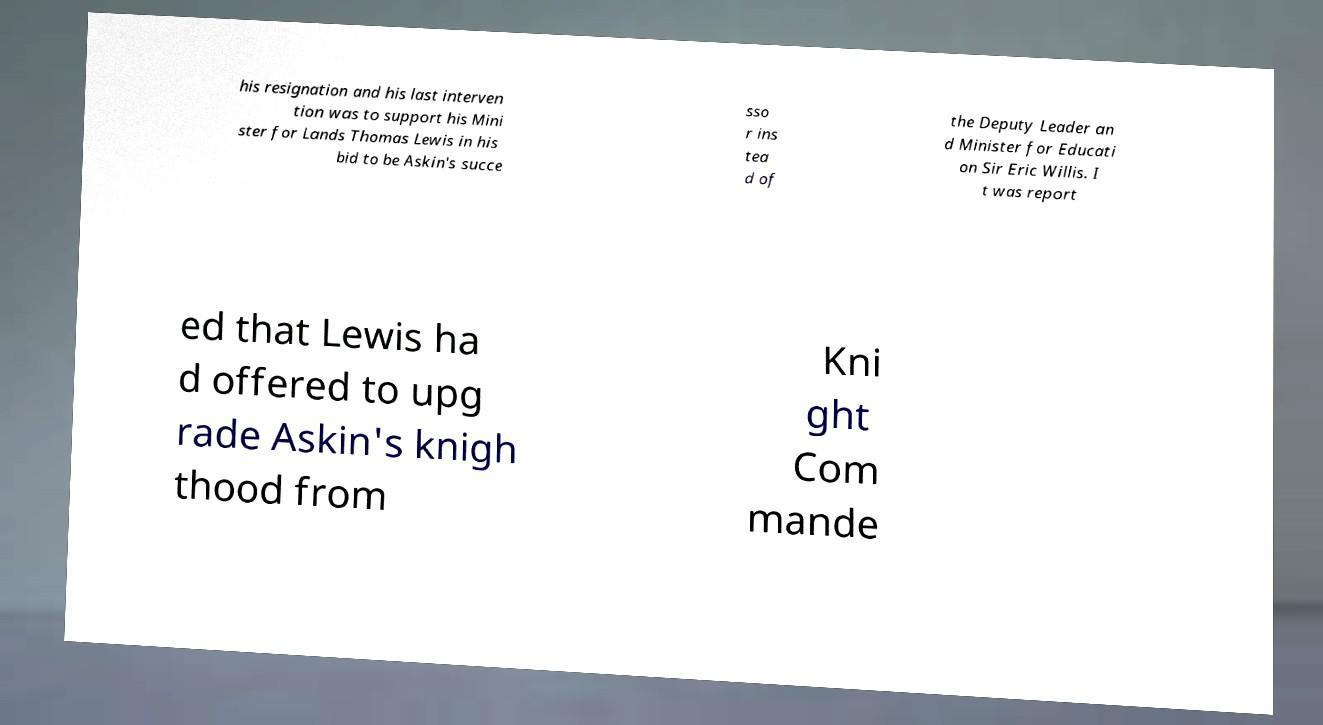Can you read and provide the text displayed in the image?This photo seems to have some interesting text. Can you extract and type it out for me? his resignation and his last interven tion was to support his Mini ster for Lands Thomas Lewis in his bid to be Askin's succe sso r ins tea d of the Deputy Leader an d Minister for Educati on Sir Eric Willis. I t was report ed that Lewis ha d offered to upg rade Askin's knigh thood from Kni ght Com mande 